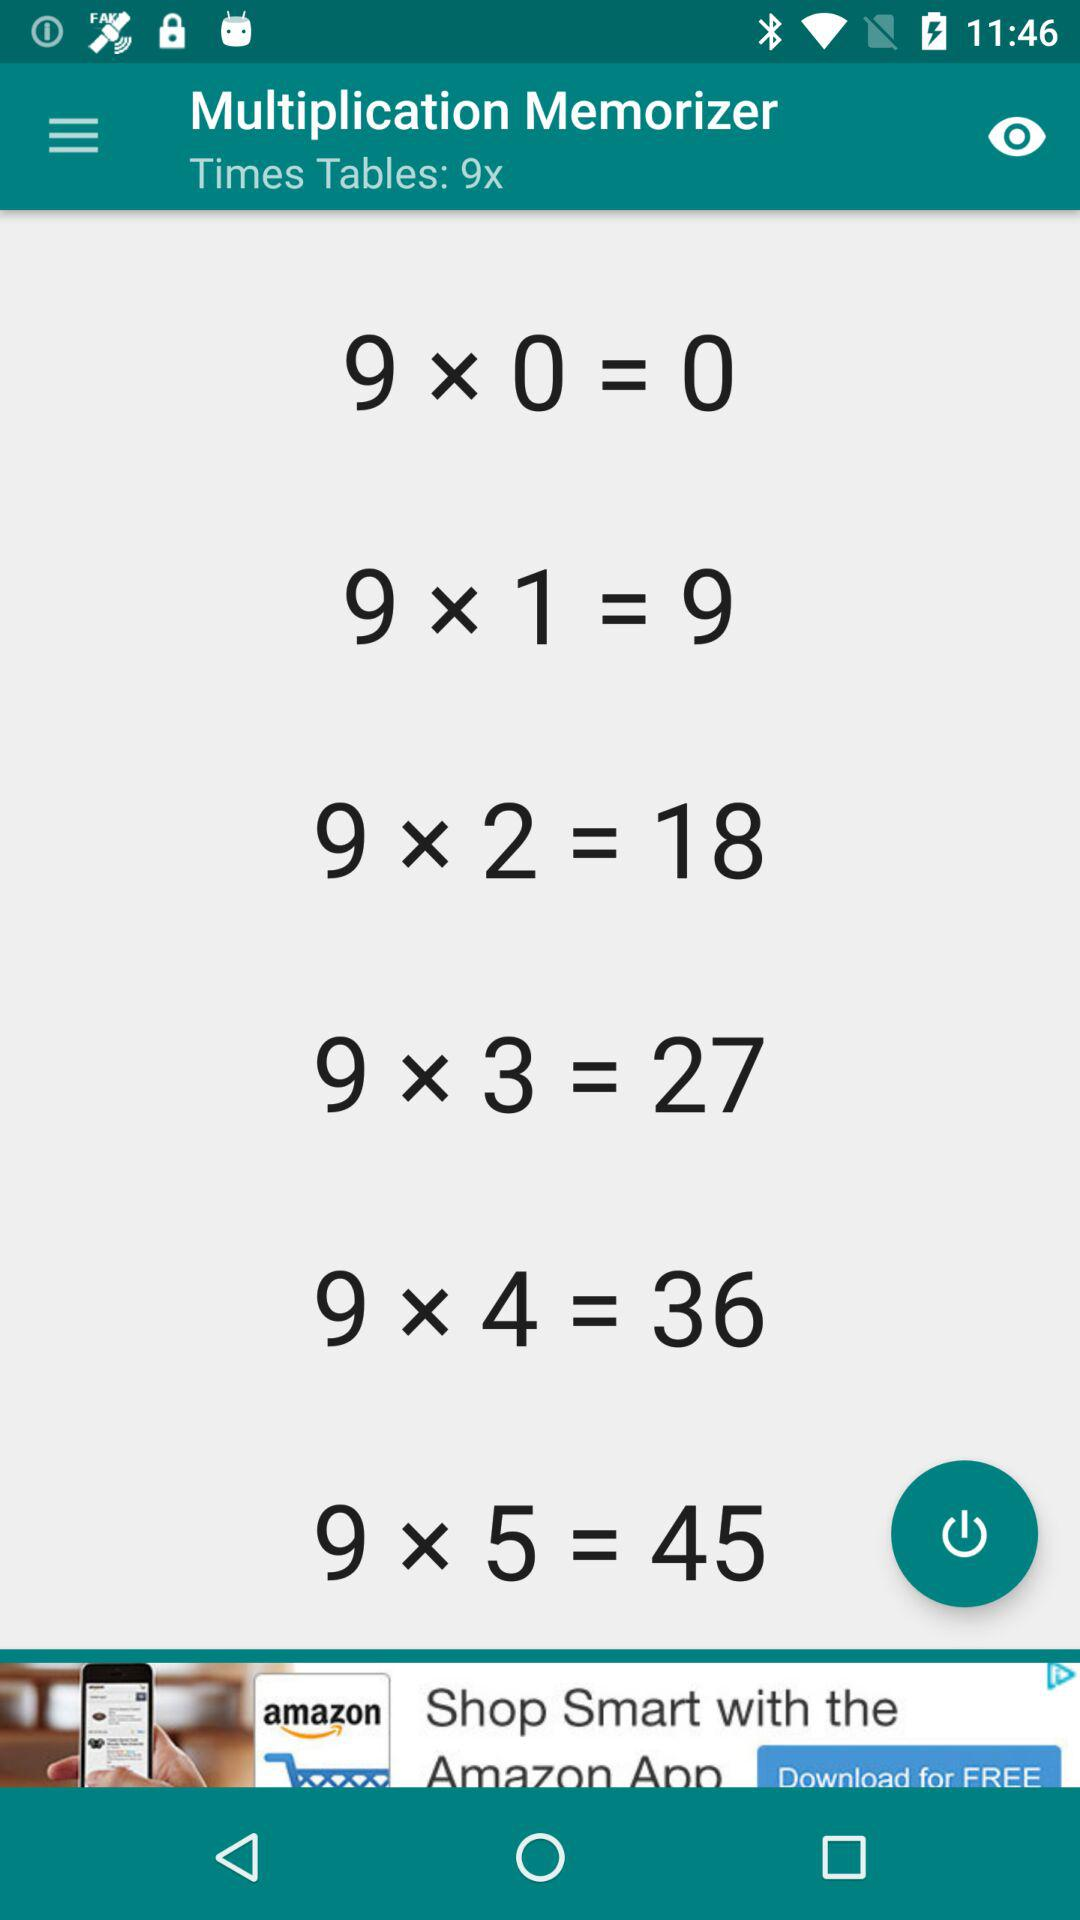What is the difference between the largest and smallest numbers in the table?
Answer the question using a single word or phrase. 45 